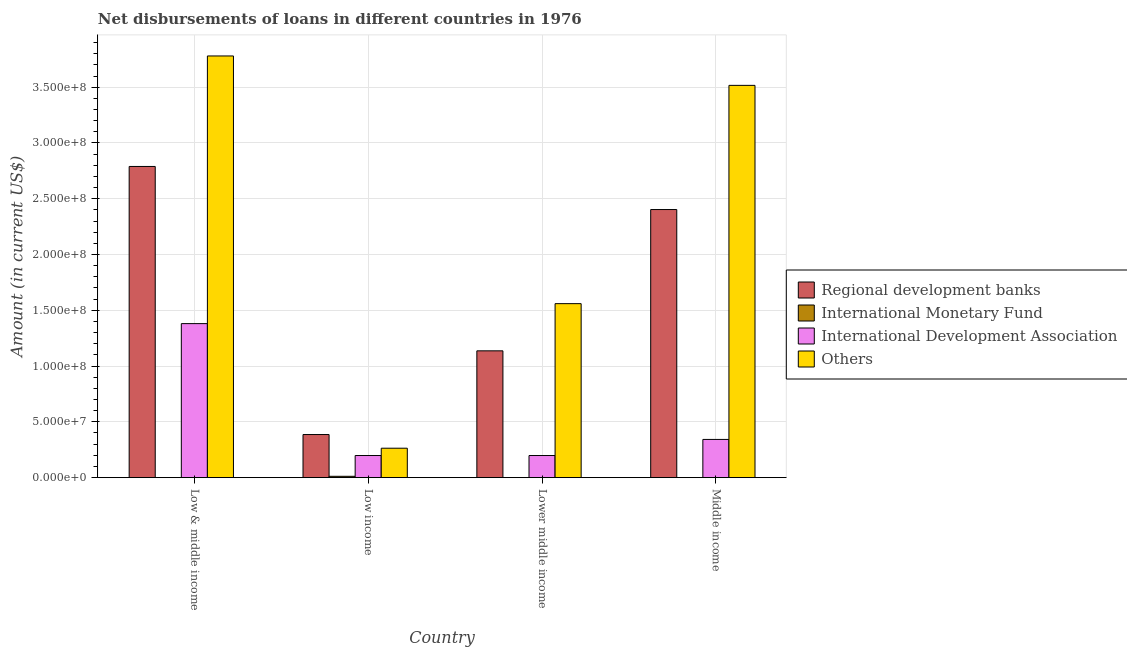How many different coloured bars are there?
Your answer should be very brief. 4. How many groups of bars are there?
Your response must be concise. 4. Are the number of bars per tick equal to the number of legend labels?
Offer a very short reply. No. How many bars are there on the 2nd tick from the left?
Make the answer very short. 4. How many bars are there on the 3rd tick from the right?
Keep it short and to the point. 4. What is the amount of loan disimbursed by regional development banks in Low income?
Your answer should be very brief. 3.86e+07. Across all countries, what is the maximum amount of loan disimbursed by other organisations?
Your answer should be compact. 3.78e+08. Across all countries, what is the minimum amount of loan disimbursed by regional development banks?
Provide a succinct answer. 3.86e+07. In which country was the amount of loan disimbursed by international development association maximum?
Keep it short and to the point. Low & middle income. What is the total amount of loan disimbursed by regional development banks in the graph?
Give a very brief answer. 6.71e+08. What is the difference between the amount of loan disimbursed by regional development banks in Low & middle income and that in Low income?
Your response must be concise. 2.40e+08. What is the difference between the amount of loan disimbursed by other organisations in Middle income and the amount of loan disimbursed by international development association in Low & middle income?
Give a very brief answer. 2.14e+08. What is the average amount of loan disimbursed by other organisations per country?
Ensure brevity in your answer.  2.28e+08. What is the difference between the amount of loan disimbursed by international development association and amount of loan disimbursed by regional development banks in Low & middle income?
Give a very brief answer. -1.41e+08. What is the ratio of the amount of loan disimbursed by international development association in Low income to that in Lower middle income?
Keep it short and to the point. 1. Is the difference between the amount of loan disimbursed by other organisations in Low & middle income and Middle income greater than the difference between the amount of loan disimbursed by international development association in Low & middle income and Middle income?
Offer a very short reply. No. What is the difference between the highest and the second highest amount of loan disimbursed by regional development banks?
Offer a very short reply. 3.86e+07. What is the difference between the highest and the lowest amount of loan disimbursed by other organisations?
Make the answer very short. 3.52e+08. Is it the case that in every country, the sum of the amount of loan disimbursed by other organisations and amount of loan disimbursed by international monetary fund is greater than the sum of amount of loan disimbursed by regional development banks and amount of loan disimbursed by international development association?
Provide a short and direct response. No. What is the difference between two consecutive major ticks on the Y-axis?
Offer a very short reply. 5.00e+07. Does the graph contain any zero values?
Give a very brief answer. Yes. Does the graph contain grids?
Keep it short and to the point. Yes. Where does the legend appear in the graph?
Your answer should be very brief. Center right. How are the legend labels stacked?
Offer a very short reply. Vertical. What is the title of the graph?
Your response must be concise. Net disbursements of loans in different countries in 1976. Does "HFC gas" appear as one of the legend labels in the graph?
Offer a very short reply. No. What is the Amount (in current US$) of Regional development banks in Low & middle income?
Keep it short and to the point. 2.79e+08. What is the Amount (in current US$) in International Development Association in Low & middle income?
Provide a short and direct response. 1.38e+08. What is the Amount (in current US$) in Others in Low & middle income?
Give a very brief answer. 3.78e+08. What is the Amount (in current US$) of Regional development banks in Low income?
Keep it short and to the point. 3.86e+07. What is the Amount (in current US$) of International Monetary Fund in Low income?
Your answer should be very brief. 1.18e+06. What is the Amount (in current US$) of International Development Association in Low income?
Your answer should be compact. 1.98e+07. What is the Amount (in current US$) of Others in Low income?
Provide a short and direct response. 2.64e+07. What is the Amount (in current US$) in Regional development banks in Lower middle income?
Give a very brief answer. 1.14e+08. What is the Amount (in current US$) of International Development Association in Lower middle income?
Your answer should be compact. 1.98e+07. What is the Amount (in current US$) in Others in Lower middle income?
Offer a very short reply. 1.56e+08. What is the Amount (in current US$) in Regional development banks in Middle income?
Offer a terse response. 2.40e+08. What is the Amount (in current US$) of International Development Association in Middle income?
Your response must be concise. 3.42e+07. What is the Amount (in current US$) in Others in Middle income?
Provide a succinct answer. 3.52e+08. Across all countries, what is the maximum Amount (in current US$) of Regional development banks?
Offer a very short reply. 2.79e+08. Across all countries, what is the maximum Amount (in current US$) of International Monetary Fund?
Provide a succinct answer. 1.18e+06. Across all countries, what is the maximum Amount (in current US$) in International Development Association?
Offer a very short reply. 1.38e+08. Across all countries, what is the maximum Amount (in current US$) of Others?
Make the answer very short. 3.78e+08. Across all countries, what is the minimum Amount (in current US$) in Regional development banks?
Keep it short and to the point. 3.86e+07. Across all countries, what is the minimum Amount (in current US$) in International Development Association?
Keep it short and to the point. 1.98e+07. Across all countries, what is the minimum Amount (in current US$) of Others?
Your answer should be compact. 2.64e+07. What is the total Amount (in current US$) of Regional development banks in the graph?
Your answer should be very brief. 6.71e+08. What is the total Amount (in current US$) in International Monetary Fund in the graph?
Offer a very short reply. 1.18e+06. What is the total Amount (in current US$) of International Development Association in the graph?
Offer a very short reply. 2.12e+08. What is the total Amount (in current US$) of Others in the graph?
Your response must be concise. 9.12e+08. What is the difference between the Amount (in current US$) of Regional development banks in Low & middle income and that in Low income?
Your response must be concise. 2.40e+08. What is the difference between the Amount (in current US$) of International Development Association in Low & middle income and that in Low income?
Your response must be concise. 1.18e+08. What is the difference between the Amount (in current US$) in Others in Low & middle income and that in Low income?
Keep it short and to the point. 3.52e+08. What is the difference between the Amount (in current US$) of Regional development banks in Low & middle income and that in Lower middle income?
Offer a terse response. 1.65e+08. What is the difference between the Amount (in current US$) of International Development Association in Low & middle income and that in Lower middle income?
Ensure brevity in your answer.  1.18e+08. What is the difference between the Amount (in current US$) of Others in Low & middle income and that in Lower middle income?
Offer a terse response. 2.22e+08. What is the difference between the Amount (in current US$) in Regional development banks in Low & middle income and that in Middle income?
Keep it short and to the point. 3.86e+07. What is the difference between the Amount (in current US$) of International Development Association in Low & middle income and that in Middle income?
Provide a short and direct response. 1.04e+08. What is the difference between the Amount (in current US$) of Others in Low & middle income and that in Middle income?
Your response must be concise. 2.64e+07. What is the difference between the Amount (in current US$) in Regional development banks in Low income and that in Lower middle income?
Offer a very short reply. -7.50e+07. What is the difference between the Amount (in current US$) in International Development Association in Low income and that in Lower middle income?
Provide a short and direct response. 0. What is the difference between the Amount (in current US$) in Others in Low income and that in Lower middle income?
Offer a terse response. -1.30e+08. What is the difference between the Amount (in current US$) of Regional development banks in Low income and that in Middle income?
Your answer should be compact. -2.02e+08. What is the difference between the Amount (in current US$) of International Development Association in Low income and that in Middle income?
Your answer should be very brief. -1.44e+07. What is the difference between the Amount (in current US$) of Others in Low income and that in Middle income?
Provide a succinct answer. -3.25e+08. What is the difference between the Amount (in current US$) in Regional development banks in Lower middle income and that in Middle income?
Keep it short and to the point. -1.27e+08. What is the difference between the Amount (in current US$) of International Development Association in Lower middle income and that in Middle income?
Offer a very short reply. -1.44e+07. What is the difference between the Amount (in current US$) in Others in Lower middle income and that in Middle income?
Give a very brief answer. -1.96e+08. What is the difference between the Amount (in current US$) of Regional development banks in Low & middle income and the Amount (in current US$) of International Monetary Fund in Low income?
Your answer should be compact. 2.78e+08. What is the difference between the Amount (in current US$) of Regional development banks in Low & middle income and the Amount (in current US$) of International Development Association in Low income?
Make the answer very short. 2.59e+08. What is the difference between the Amount (in current US$) in Regional development banks in Low & middle income and the Amount (in current US$) in Others in Low income?
Make the answer very short. 2.53e+08. What is the difference between the Amount (in current US$) in International Development Association in Low & middle income and the Amount (in current US$) in Others in Low income?
Offer a very short reply. 1.12e+08. What is the difference between the Amount (in current US$) of Regional development banks in Low & middle income and the Amount (in current US$) of International Development Association in Lower middle income?
Provide a short and direct response. 2.59e+08. What is the difference between the Amount (in current US$) in Regional development banks in Low & middle income and the Amount (in current US$) in Others in Lower middle income?
Your answer should be very brief. 1.23e+08. What is the difference between the Amount (in current US$) in International Development Association in Low & middle income and the Amount (in current US$) in Others in Lower middle income?
Your answer should be very brief. -1.79e+07. What is the difference between the Amount (in current US$) in Regional development banks in Low & middle income and the Amount (in current US$) in International Development Association in Middle income?
Make the answer very short. 2.45e+08. What is the difference between the Amount (in current US$) in Regional development banks in Low & middle income and the Amount (in current US$) in Others in Middle income?
Your response must be concise. -7.27e+07. What is the difference between the Amount (in current US$) of International Development Association in Low & middle income and the Amount (in current US$) of Others in Middle income?
Offer a very short reply. -2.14e+08. What is the difference between the Amount (in current US$) of Regional development banks in Low income and the Amount (in current US$) of International Development Association in Lower middle income?
Ensure brevity in your answer.  1.88e+07. What is the difference between the Amount (in current US$) of Regional development banks in Low income and the Amount (in current US$) of Others in Lower middle income?
Make the answer very short. -1.17e+08. What is the difference between the Amount (in current US$) of International Monetary Fund in Low income and the Amount (in current US$) of International Development Association in Lower middle income?
Keep it short and to the point. -1.86e+07. What is the difference between the Amount (in current US$) of International Monetary Fund in Low income and the Amount (in current US$) of Others in Lower middle income?
Ensure brevity in your answer.  -1.55e+08. What is the difference between the Amount (in current US$) of International Development Association in Low income and the Amount (in current US$) of Others in Lower middle income?
Give a very brief answer. -1.36e+08. What is the difference between the Amount (in current US$) of Regional development banks in Low income and the Amount (in current US$) of International Development Association in Middle income?
Make the answer very short. 4.38e+06. What is the difference between the Amount (in current US$) of Regional development banks in Low income and the Amount (in current US$) of Others in Middle income?
Your answer should be very brief. -3.13e+08. What is the difference between the Amount (in current US$) in International Monetary Fund in Low income and the Amount (in current US$) in International Development Association in Middle income?
Your response must be concise. -3.31e+07. What is the difference between the Amount (in current US$) of International Monetary Fund in Low income and the Amount (in current US$) of Others in Middle income?
Give a very brief answer. -3.50e+08. What is the difference between the Amount (in current US$) in International Development Association in Low income and the Amount (in current US$) in Others in Middle income?
Keep it short and to the point. -3.32e+08. What is the difference between the Amount (in current US$) of Regional development banks in Lower middle income and the Amount (in current US$) of International Development Association in Middle income?
Offer a very short reply. 7.94e+07. What is the difference between the Amount (in current US$) in Regional development banks in Lower middle income and the Amount (in current US$) in Others in Middle income?
Offer a terse response. -2.38e+08. What is the difference between the Amount (in current US$) in International Development Association in Lower middle income and the Amount (in current US$) in Others in Middle income?
Provide a short and direct response. -3.32e+08. What is the average Amount (in current US$) in Regional development banks per country?
Keep it short and to the point. 1.68e+08. What is the average Amount (in current US$) in International Monetary Fund per country?
Provide a short and direct response. 2.96e+05. What is the average Amount (in current US$) of International Development Association per country?
Make the answer very short. 5.30e+07. What is the average Amount (in current US$) in Others per country?
Offer a very short reply. 2.28e+08. What is the difference between the Amount (in current US$) in Regional development banks and Amount (in current US$) in International Development Association in Low & middle income?
Offer a terse response. 1.41e+08. What is the difference between the Amount (in current US$) in Regional development banks and Amount (in current US$) in Others in Low & middle income?
Your response must be concise. -9.91e+07. What is the difference between the Amount (in current US$) in International Development Association and Amount (in current US$) in Others in Low & middle income?
Offer a terse response. -2.40e+08. What is the difference between the Amount (in current US$) of Regional development banks and Amount (in current US$) of International Monetary Fund in Low income?
Keep it short and to the point. 3.74e+07. What is the difference between the Amount (in current US$) of Regional development banks and Amount (in current US$) of International Development Association in Low income?
Provide a succinct answer. 1.88e+07. What is the difference between the Amount (in current US$) of Regional development banks and Amount (in current US$) of Others in Low income?
Provide a succinct answer. 1.23e+07. What is the difference between the Amount (in current US$) in International Monetary Fund and Amount (in current US$) in International Development Association in Low income?
Make the answer very short. -1.86e+07. What is the difference between the Amount (in current US$) of International Monetary Fund and Amount (in current US$) of Others in Low income?
Make the answer very short. -2.52e+07. What is the difference between the Amount (in current US$) of International Development Association and Amount (in current US$) of Others in Low income?
Give a very brief answer. -6.55e+06. What is the difference between the Amount (in current US$) in Regional development banks and Amount (in current US$) in International Development Association in Lower middle income?
Provide a short and direct response. 9.38e+07. What is the difference between the Amount (in current US$) in Regional development banks and Amount (in current US$) in Others in Lower middle income?
Your response must be concise. -4.23e+07. What is the difference between the Amount (in current US$) in International Development Association and Amount (in current US$) in Others in Lower middle income?
Keep it short and to the point. -1.36e+08. What is the difference between the Amount (in current US$) in Regional development banks and Amount (in current US$) in International Development Association in Middle income?
Give a very brief answer. 2.06e+08. What is the difference between the Amount (in current US$) in Regional development banks and Amount (in current US$) in Others in Middle income?
Give a very brief answer. -1.11e+08. What is the difference between the Amount (in current US$) of International Development Association and Amount (in current US$) of Others in Middle income?
Offer a very short reply. -3.17e+08. What is the ratio of the Amount (in current US$) in Regional development banks in Low & middle income to that in Low income?
Keep it short and to the point. 7.22. What is the ratio of the Amount (in current US$) of International Development Association in Low & middle income to that in Low income?
Offer a very short reply. 6.97. What is the ratio of the Amount (in current US$) in Others in Low & middle income to that in Low income?
Make the answer very short. 14.34. What is the ratio of the Amount (in current US$) of Regional development banks in Low & middle income to that in Lower middle income?
Provide a succinct answer. 2.45. What is the ratio of the Amount (in current US$) in International Development Association in Low & middle income to that in Lower middle income?
Your response must be concise. 6.97. What is the ratio of the Amount (in current US$) of Others in Low & middle income to that in Lower middle income?
Your answer should be very brief. 2.42. What is the ratio of the Amount (in current US$) of Regional development banks in Low & middle income to that in Middle income?
Offer a terse response. 1.16. What is the ratio of the Amount (in current US$) in International Development Association in Low & middle income to that in Middle income?
Make the answer very short. 4.03. What is the ratio of the Amount (in current US$) in Others in Low & middle income to that in Middle income?
Keep it short and to the point. 1.07. What is the ratio of the Amount (in current US$) of Regional development banks in Low income to that in Lower middle income?
Provide a short and direct response. 0.34. What is the ratio of the Amount (in current US$) in Others in Low income to that in Lower middle income?
Provide a succinct answer. 0.17. What is the ratio of the Amount (in current US$) in Regional development banks in Low income to that in Middle income?
Give a very brief answer. 0.16. What is the ratio of the Amount (in current US$) in International Development Association in Low income to that in Middle income?
Your response must be concise. 0.58. What is the ratio of the Amount (in current US$) in Others in Low income to that in Middle income?
Your answer should be very brief. 0.07. What is the ratio of the Amount (in current US$) in Regional development banks in Lower middle income to that in Middle income?
Keep it short and to the point. 0.47. What is the ratio of the Amount (in current US$) of International Development Association in Lower middle income to that in Middle income?
Offer a very short reply. 0.58. What is the ratio of the Amount (in current US$) of Others in Lower middle income to that in Middle income?
Keep it short and to the point. 0.44. What is the difference between the highest and the second highest Amount (in current US$) of Regional development banks?
Your answer should be very brief. 3.86e+07. What is the difference between the highest and the second highest Amount (in current US$) in International Development Association?
Provide a short and direct response. 1.04e+08. What is the difference between the highest and the second highest Amount (in current US$) in Others?
Provide a succinct answer. 2.64e+07. What is the difference between the highest and the lowest Amount (in current US$) of Regional development banks?
Ensure brevity in your answer.  2.40e+08. What is the difference between the highest and the lowest Amount (in current US$) of International Monetary Fund?
Your response must be concise. 1.18e+06. What is the difference between the highest and the lowest Amount (in current US$) in International Development Association?
Offer a terse response. 1.18e+08. What is the difference between the highest and the lowest Amount (in current US$) in Others?
Make the answer very short. 3.52e+08. 